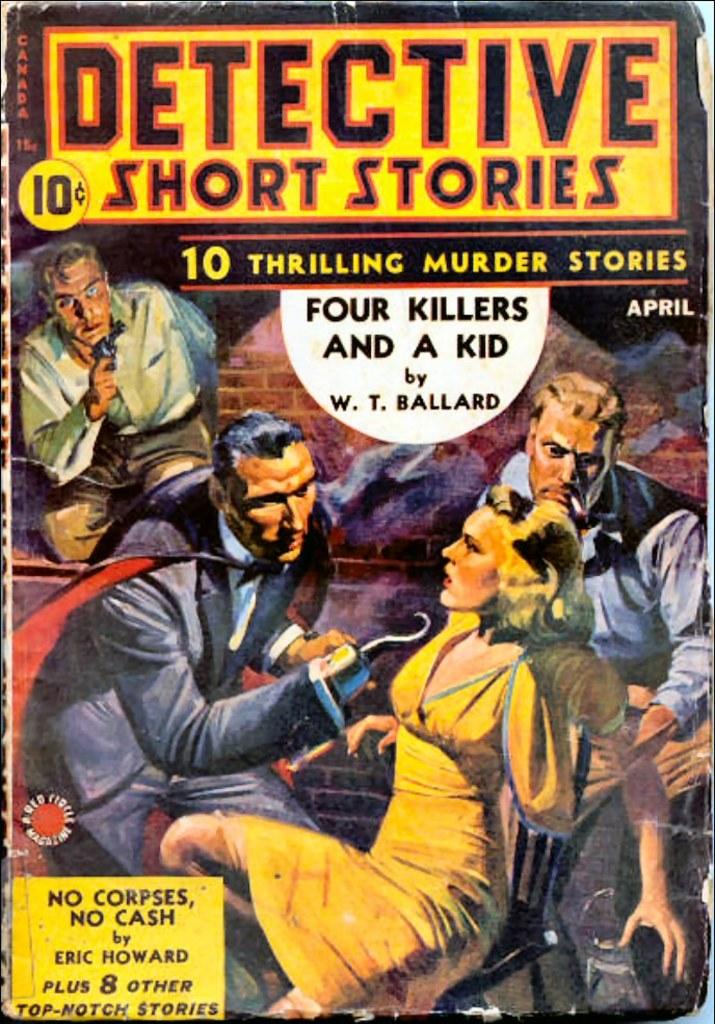How much was the comic?
Offer a terse response. 10 cents. How many stories are in this book?
Keep it short and to the point. 10. 